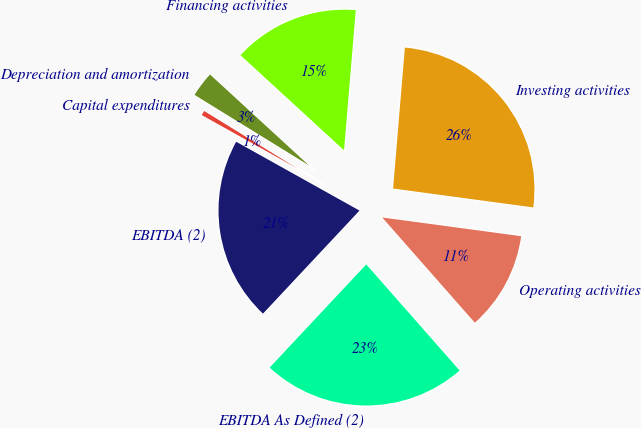<chart> <loc_0><loc_0><loc_500><loc_500><pie_chart><fcel>Operating activities<fcel>Investing activities<fcel>Financing activities<fcel>Depreciation and amortization<fcel>Capital expenditures<fcel>EBITDA (2)<fcel>EBITDA As Defined (2)<nl><fcel>11.38%<fcel>25.8%<fcel>14.5%<fcel>3.03%<fcel>0.69%<fcel>21.12%<fcel>23.46%<nl></chart> 